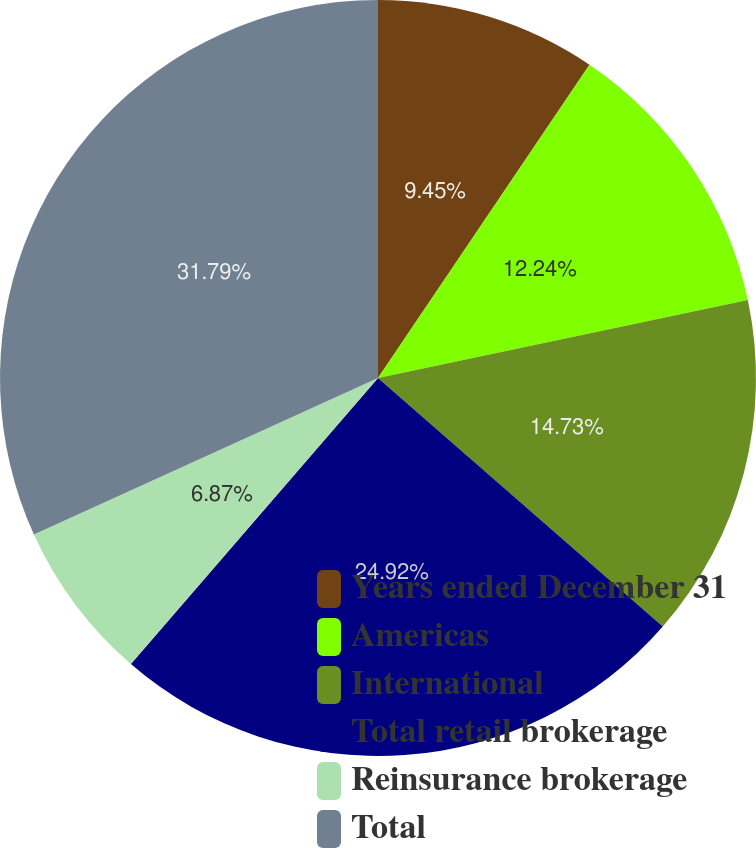<chart> <loc_0><loc_0><loc_500><loc_500><pie_chart><fcel>Years ended December 31<fcel>Americas<fcel>International<fcel>Total retail brokerage<fcel>Reinsurance brokerage<fcel>Total<nl><fcel>9.45%<fcel>12.24%<fcel>14.73%<fcel>24.92%<fcel>6.87%<fcel>31.79%<nl></chart> 